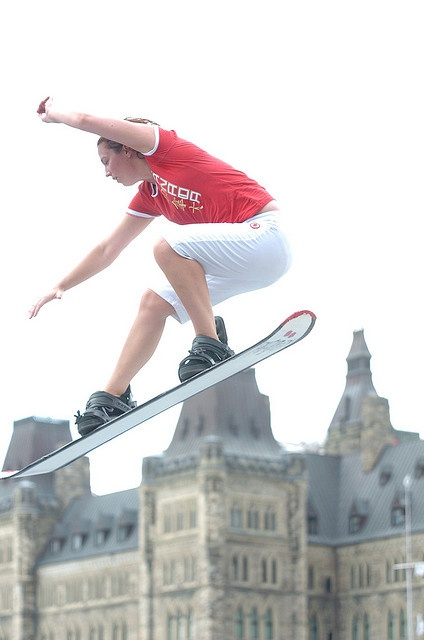Describe the objects in this image and their specific colors. I can see people in white, darkgray, lightpink, and salmon tones and snowboard in white, lightgray, darkgray, lightblue, and gray tones in this image. 